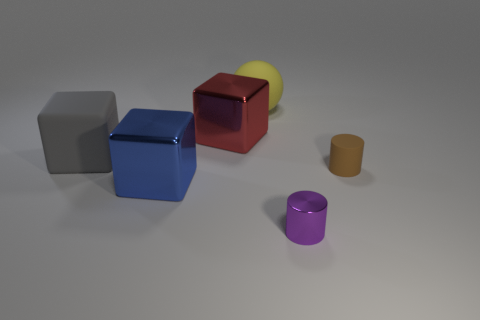Are there more big gray cubes that are in front of the small brown matte object than blue shiny objects that are on the right side of the large blue shiny object?
Your answer should be very brief. No. Is there any other thing that is the same color as the rubber cylinder?
Your answer should be compact. No. What number of things are either gray metallic things or big cubes?
Your answer should be compact. 3. There is a cylinder to the right of the purple metal object; is it the same size as the tiny metal cylinder?
Give a very brief answer. Yes. What number of other things are the same size as the yellow thing?
Offer a terse response. 3. Are any blue blocks visible?
Your response must be concise. Yes. There is a shiny thing behind the tiny cylinder to the right of the purple metal cylinder; how big is it?
Make the answer very short. Large. The matte object that is both to the right of the big blue shiny thing and left of the tiny brown rubber object is what color?
Your answer should be compact. Yellow. What number of other things are the same shape as the tiny brown thing?
Provide a short and direct response. 1. The matte cube that is the same size as the yellow rubber thing is what color?
Keep it short and to the point. Gray. 